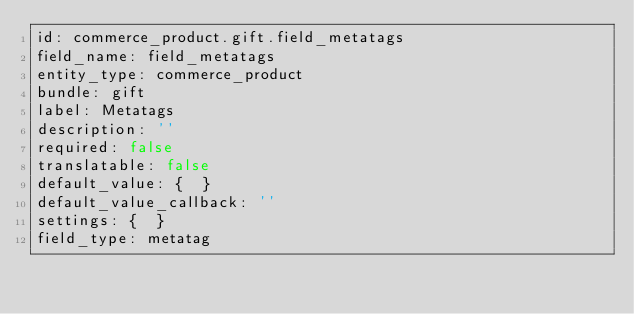<code> <loc_0><loc_0><loc_500><loc_500><_YAML_>id: commerce_product.gift.field_metatags
field_name: field_metatags
entity_type: commerce_product
bundle: gift
label: Metatags
description: ''
required: false
translatable: false
default_value: {  }
default_value_callback: ''
settings: {  }
field_type: metatag
</code> 